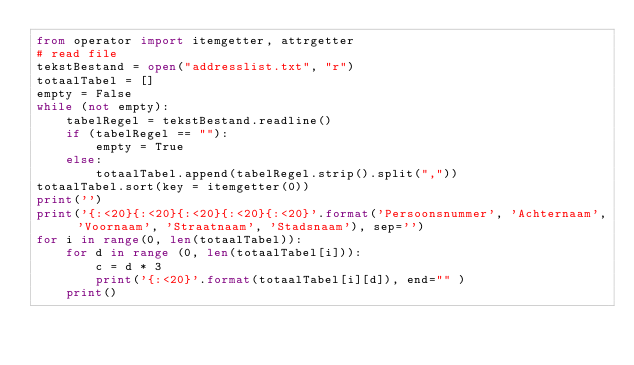<code> <loc_0><loc_0><loc_500><loc_500><_Python_>from operator import itemgetter, attrgetter
# read file
tekstBestand = open("addresslist.txt", "r")
totaalTabel = []
empty = False
while (not empty):
    tabelRegel = tekstBestand.readline()
    if (tabelRegel == ""):
        empty = True
    else:
        totaalTabel.append(tabelRegel.strip().split(","))
totaalTabel.sort(key = itemgetter(0))
print('')
print('{:<20}{:<20}{:<20}{:<20}{:<20}'.format('Persoonsnummer', 'Achternaam', 'Voornaam', 'Straatnaam', 'Stadsnaam'), sep='')
for i in range(0, len(totaalTabel)):
    for d in range (0, len(totaalTabel[i])):
        c = d * 3
        print('{:<20}'.format(totaalTabel[i][d]), end="" )
    print()
</code> 